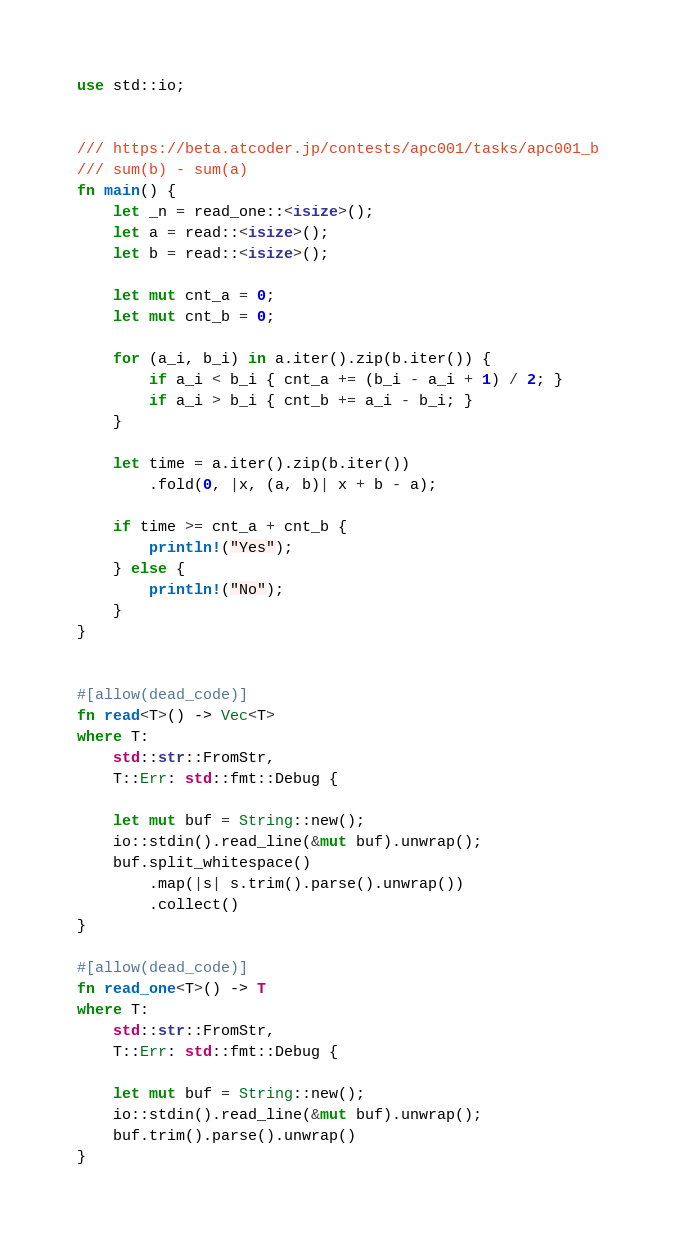Convert code to text. <code><loc_0><loc_0><loc_500><loc_500><_Rust_>use std::io;


/// https://beta.atcoder.jp/contests/apc001/tasks/apc001_b
/// sum(b) - sum(a)
fn main() {
    let _n = read_one::<isize>();
    let a = read::<isize>();
    let b = read::<isize>();

    let mut cnt_a = 0;
    let mut cnt_b = 0;

    for (a_i, b_i) in a.iter().zip(b.iter()) {
        if a_i < b_i { cnt_a += (b_i - a_i + 1) / 2; }
        if a_i > b_i { cnt_b += a_i - b_i; }
    }

    let time = a.iter().zip(b.iter())
        .fold(0, |x, (a, b)| x + b - a);

    if time >= cnt_a + cnt_b {
        println!("Yes");
    } else {
        println!("No");
    }
}


#[allow(dead_code)]
fn read<T>() -> Vec<T>
where T:
    std::str::FromStr,
    T::Err: std::fmt::Debug {

    let mut buf = String::new();
    io::stdin().read_line(&mut buf).unwrap();
    buf.split_whitespace()
        .map(|s| s.trim().parse().unwrap())
        .collect()
}

#[allow(dead_code)]
fn read_one<T>() -> T
where T:
    std::str::FromStr,
    T::Err: std::fmt::Debug {

    let mut buf = String::new();
    io::stdin().read_line(&mut buf).unwrap();
    buf.trim().parse().unwrap()
}</code> 